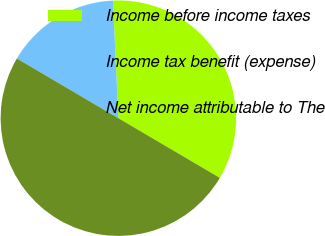<chart> <loc_0><loc_0><loc_500><loc_500><pie_chart><fcel>Income before income taxes<fcel>Income tax benefit (expense)<fcel>Net income attributable to The<nl><fcel>34.19%<fcel>15.81%<fcel>50.0%<nl></chart> 